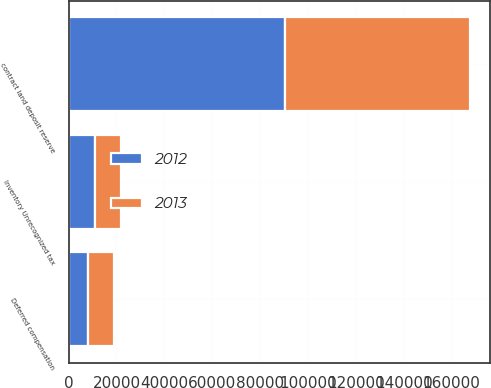Convert chart to OTSL. <chart><loc_0><loc_0><loc_500><loc_500><stacked_bar_chart><ecel><fcel>contract land deposit reserve<fcel>Deferred compensation<fcel>Inventory Unrecognized tax<nl><fcel>2012<fcel>90372<fcel>8049<fcel>11099<nl><fcel>2013<fcel>77475<fcel>10923<fcel>10914<nl></chart> 